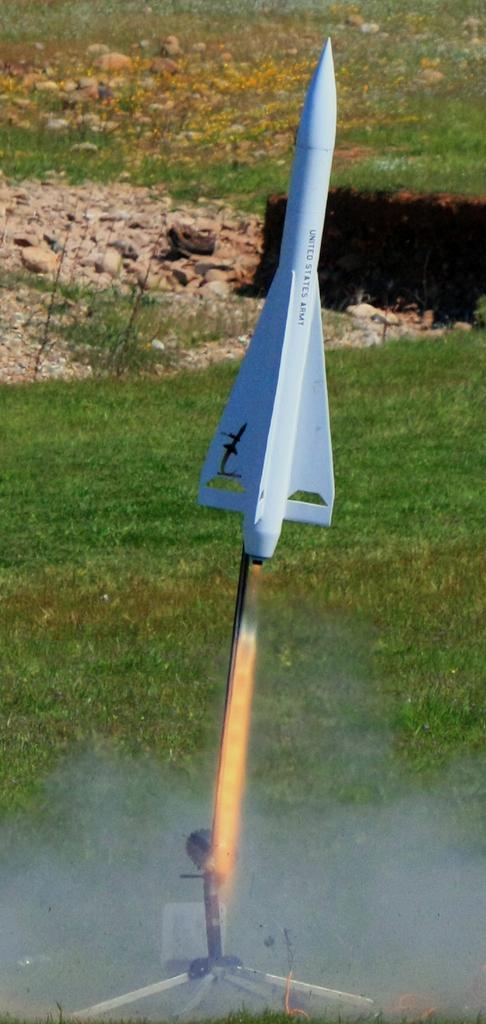In one or two sentences, can you explain what this image depicts? In this image I can see a white color rocket. In the background I can see rocks, the grass and some objects on the ground. 